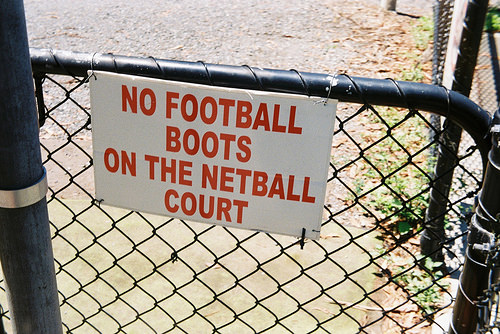<image>
Is there a board on the gate? Yes. Looking at the image, I can see the board is positioned on top of the gate, with the gate providing support. 